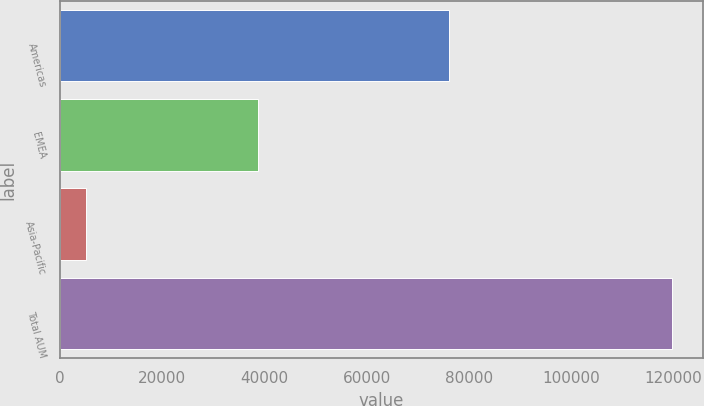Convert chart to OTSL. <chart><loc_0><loc_0><loc_500><loc_500><bar_chart><fcel>Americas<fcel>EMEA<fcel>Asia-Pacific<fcel>Total AUM<nl><fcel>76017<fcel>38743<fcel>4967<fcel>119727<nl></chart> 